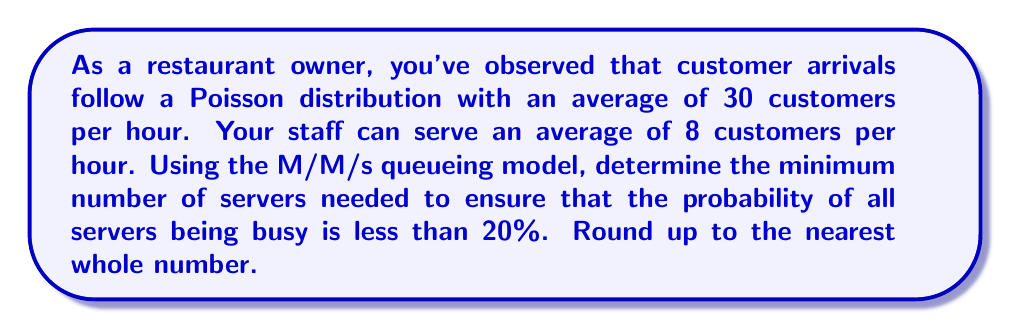What is the answer to this math problem? Let's approach this step-by-step using the M/M/s queueing model:

1) Define the variables:
   $\lambda$ = arrival rate = 30 customers/hour
   $\mu$ = service rate per server = 8 customers/hour
   $s$ = number of servers (what we're solving for)
   $P_0$ = probability of all servers being busy (should be < 0.20)

2) The utilization factor $\rho$ is given by:
   $$\rho = \frac{\lambda}{s\mu}$$

3) In the M/M/s model, the probability of all servers being busy is:
   $$P_0 = \left[\sum_{n=0}^{s-1}\frac{(s\rho)^n}{n!} + \frac{(s\rho)^s}{s!(1-\rho)}\right]^{-1}$$

4) We need to find the smallest $s$ such that $P_0 < 0.20$

5) Let's start with $s = 4$:
   $$\rho = \frac{30}{4 * 8} = 0.9375$$
   
   This is too high as $\rho$ should be less than 1 for a stable system.

6) Try $s = 5$:
   $$\rho = \frac{30}{5 * 8} = 0.75$$
   
   Calculating $P_0$ (using a calculator or computer):
   $$P_0 \approx 0.0316$$

7) Since $0.0316 < 0.20$, 5 servers is sufficient.

Therefore, the minimum number of servers needed is 5.
Answer: 5 servers 